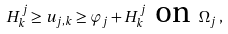Convert formula to latex. <formula><loc_0><loc_0><loc_500><loc_500>H _ { k } ^ { j } \geq u _ { j , k } \geq \varphi _ { j } + H _ { k } ^ { j } \, \text { on } \, \Omega _ { j } \, ,</formula> 